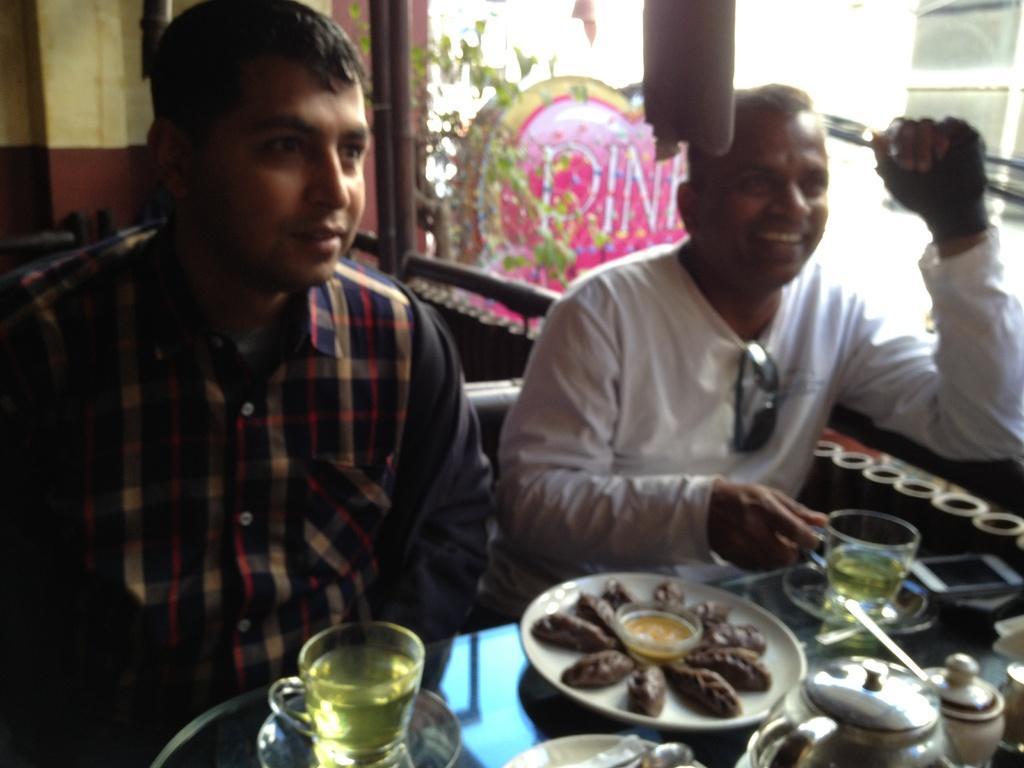Describe this image in one or two sentences. In the image there are two men sitting in front with food,tea,cups,kettles on it, on the right side there is glass wall. 